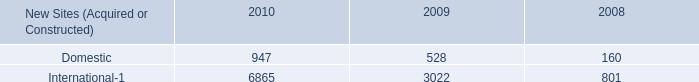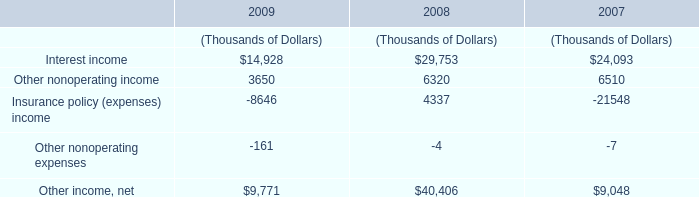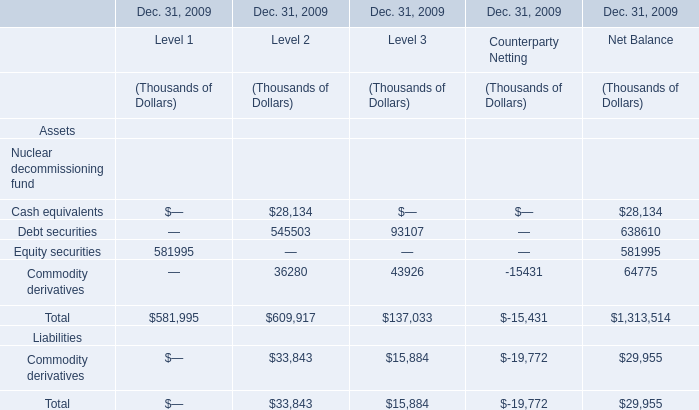which section is Total the largest for Level 2 ? 
Answer: Net Balance. 